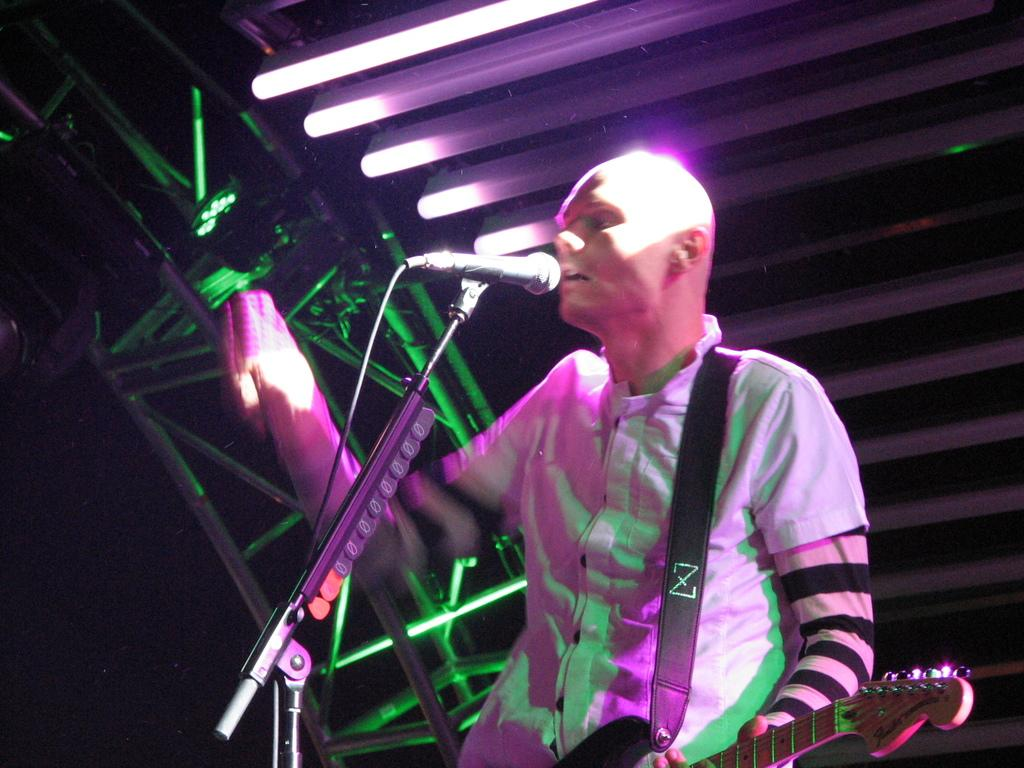What is the person in the image doing? The person is standing in the image and holding a guitar in his hands. What object is in front of the person? There is a microphone in front of the person. What can be seen in the background of the image? There are lights and metal rods visible in the background. Can you see the mother holding a cracker in the image? There is no mother or cracker present in the image. 